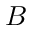Convert formula to latex. <formula><loc_0><loc_0><loc_500><loc_500>B</formula> 